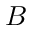Convert formula to latex. <formula><loc_0><loc_0><loc_500><loc_500>B</formula> 